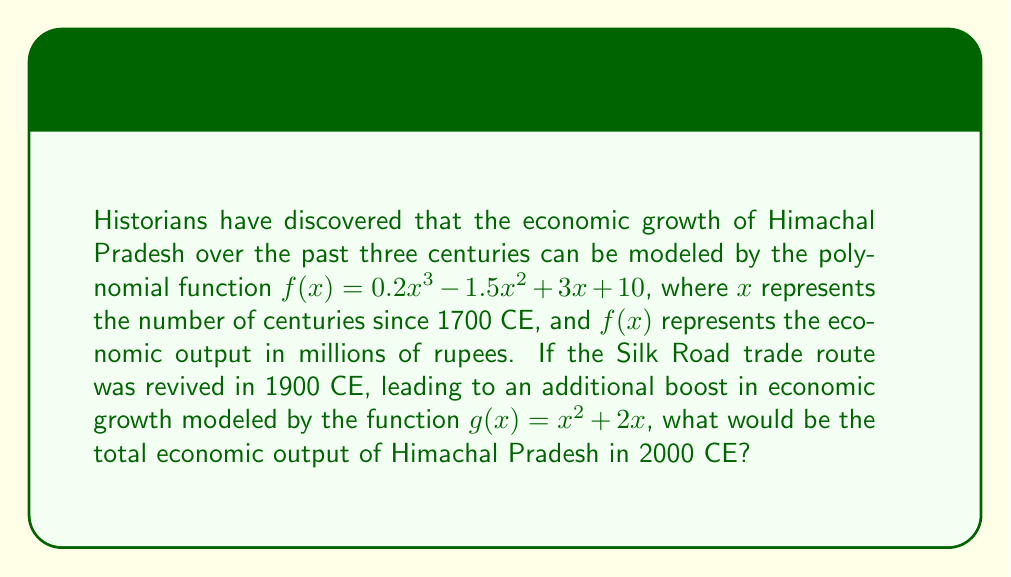Can you answer this question? To solve this problem, we need to follow these steps:

1. Determine the value of $x$ for the year 2000 CE:
   2000 CE is 3 centuries after 1700 CE, so $x = 3$

2. Calculate the economic output using the original function $f(x)$:
   $f(3) = 0.2(3^3) - 1.5(3^2) + 3(3) + 10$
   $= 0.2(27) - 1.5(9) + 9 + 10$
   $= 5.4 - 13.5 + 19$
   $= 10.9$ million rupees

3. Calculate the additional boost from the Silk Road revival using $g(x)$:
   The Silk Road was revived in 1900 CE, which is 1 century before 2000 CE.
   So, we need to calculate $g(1)$:
   $g(1) = 1^2 + 2(1) = 1 + 2 = 3$ million rupees

4. Sum the results from steps 2 and 3 to get the total economic output:
   Total output = $f(3) + g(1) = 10.9 + 3 = 13.9$ million rupees
Answer: The total economic output of Himachal Pradesh in 2000 CE would be 13.9 million rupees. 